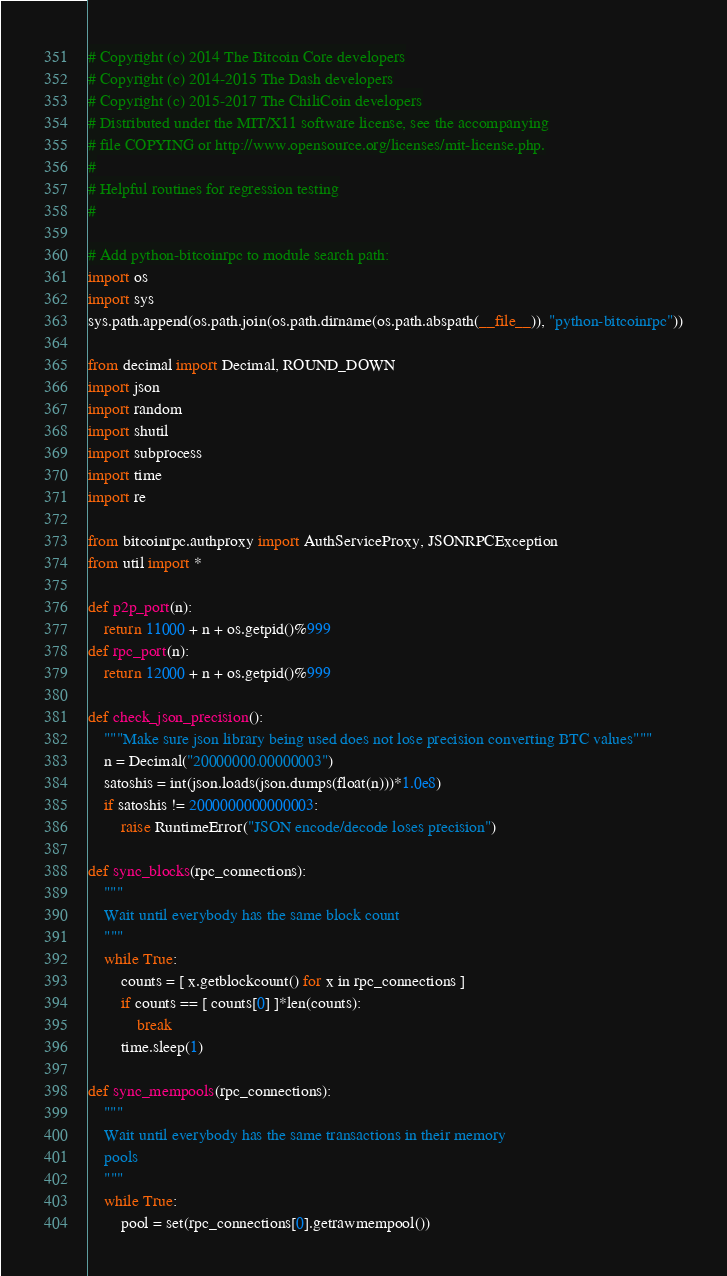Convert code to text. <code><loc_0><loc_0><loc_500><loc_500><_Python_># Copyright (c) 2014 The Bitcoin Core developers
# Copyright (c) 2014-2015 The Dash developers
# Copyright (c) 2015-2017 The ChiliCoin developers
# Distributed under the MIT/X11 software license, see the accompanying
# file COPYING or http://www.opensource.org/licenses/mit-license.php.
#
# Helpful routines for regression testing
#

# Add python-bitcoinrpc to module search path:
import os
import sys
sys.path.append(os.path.join(os.path.dirname(os.path.abspath(__file__)), "python-bitcoinrpc"))

from decimal import Decimal, ROUND_DOWN
import json
import random
import shutil
import subprocess
import time
import re

from bitcoinrpc.authproxy import AuthServiceProxy, JSONRPCException
from util import *

def p2p_port(n):
    return 11000 + n + os.getpid()%999
def rpc_port(n):
    return 12000 + n + os.getpid()%999

def check_json_precision():
    """Make sure json library being used does not lose precision converting BTC values"""
    n = Decimal("20000000.00000003")
    satoshis = int(json.loads(json.dumps(float(n)))*1.0e8)
    if satoshis != 2000000000000003:
        raise RuntimeError("JSON encode/decode loses precision")

def sync_blocks(rpc_connections):
    """
    Wait until everybody has the same block count
    """
    while True:
        counts = [ x.getblockcount() for x in rpc_connections ]
        if counts == [ counts[0] ]*len(counts):
            break
        time.sleep(1)

def sync_mempools(rpc_connections):
    """
    Wait until everybody has the same transactions in their memory
    pools
    """
    while True:
        pool = set(rpc_connections[0].getrawmempool())</code> 